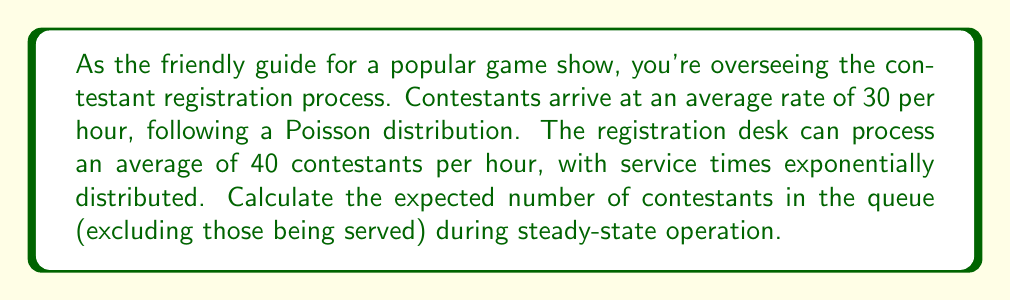Give your solution to this math problem. To solve this problem, we'll use the M/M/1 queuing model and follow these steps:

1) First, let's identify our parameters:
   $\lambda$ = arrival rate = 30 contestants/hour
   $\mu$ = service rate = 40 contestants/hour

2) Calculate the utilization factor $\rho$:
   $$\rho = \frac{\lambda}{\mu} = \frac{30}{40} = 0.75$$

3) For an M/M/1 queue, the expected number of customers in the queue (excluding those being served) is given by:
   $$L_q = \frac{\rho^2}{1-\rho}$$

4) Substitute our calculated $\rho$ into this formula:
   $$L_q = \frac{0.75^2}{1-0.75} = \frac{0.5625}{0.25} = 2.25$$

Therefore, the expected number of contestants in the queue (excluding those being served) during steady-state operation is 2.25.
Answer: 2.25 contestants 